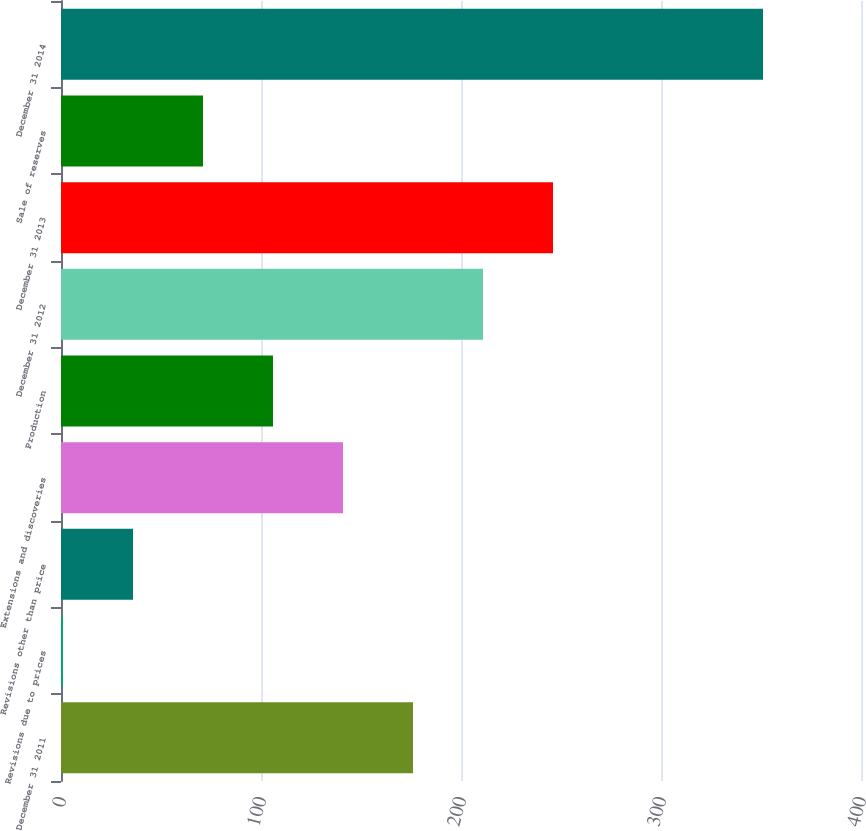Convert chart. <chart><loc_0><loc_0><loc_500><loc_500><bar_chart><fcel>December 31 2011<fcel>Revisions due to prices<fcel>Revisions other than price<fcel>Extensions and discoveries<fcel>Production<fcel>December 31 2012<fcel>December 31 2013<fcel>Sale of reserves<fcel>December 31 2014<nl><fcel>176<fcel>1<fcel>36<fcel>141<fcel>106<fcel>211<fcel>246<fcel>71<fcel>351<nl></chart> 